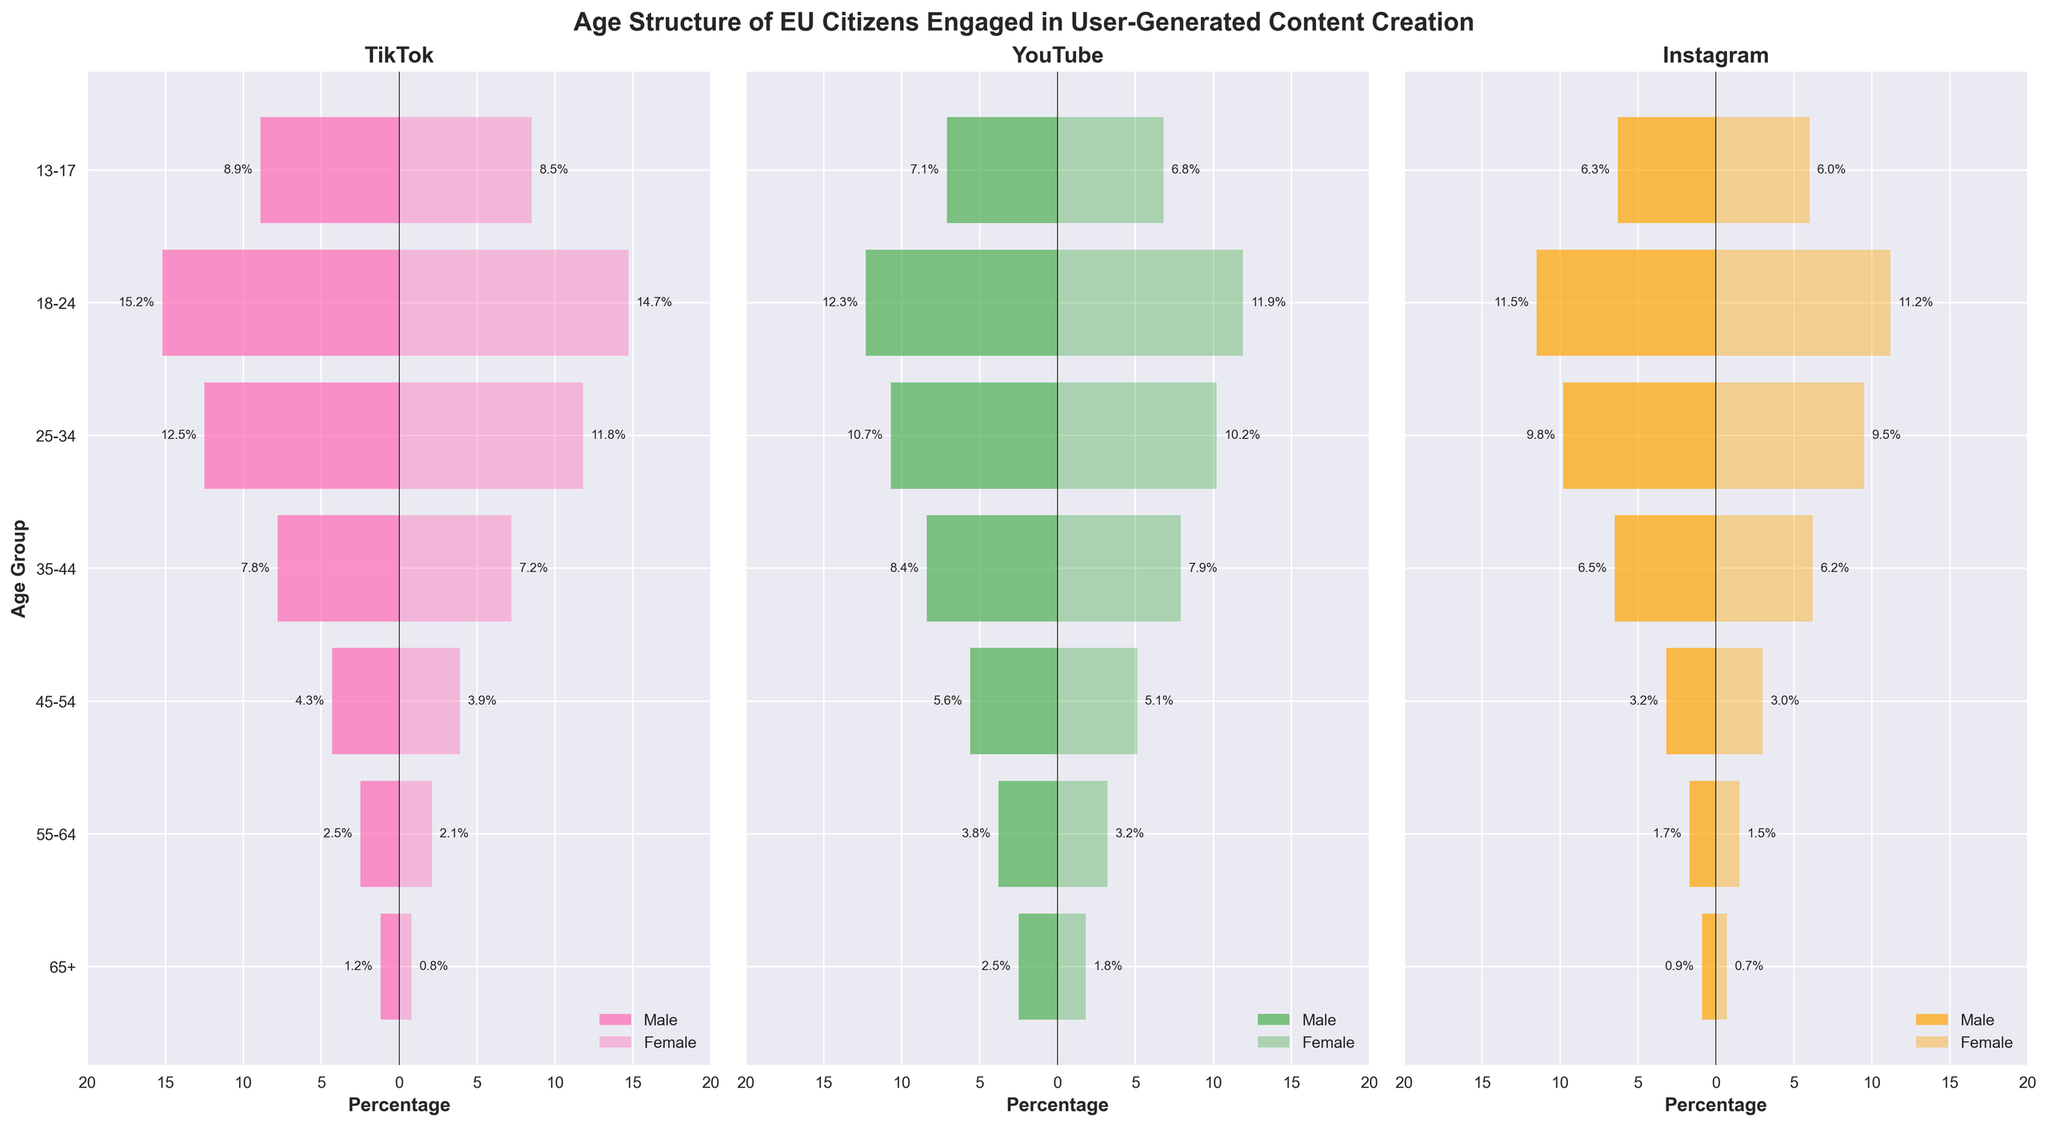What is the title of the figure? The title of the figure is usually located at the top, central portion of the figure. The title here is given as 'Age Structure of EU Citizens Engaged in User-Generated Content Creation'.
Answer: Age Structure of EU Citizens Engaged in User-Generated Content Creation Which age group has the highest engagement in TikTok among males? To find the highest engagement, we look at the 'Male TikTok' bar for each age group and identify which bar has the largest percentage. The highest percentage for males on TikTok is 15.2% in the 18-24 age group.
Answer: 18-24 What is the percentage of females aged 25-34 on YouTube? Locate the 'Female YouTube' bar for the 25-34 age group, and check the percentage value displayed alongside the bar, which is 10.2%.
Answer: 10.2% Which platform has the highest engagement for the 13-17 age group? Compare the percentages for both males and females across all platforms (TikTok, YouTube, Instagram) for the 13-17 age group. TikTok shows the highest engagement with males at 8.9% and females at 8.5%.
Answer: TikTok How does male engagement on Instagram differ between the 45-54 and 55-64 age groups? First, find the values for 'Male Instagram' for the 45-54 age group (3.2%) and the 55-64 age group (1.7%). Then calculate the difference: 3.2% - 1.7% = 1.5%.
Answer: 1.5% Which gender has higher engagement on YouTube for the 35-44 age group? Look at the 'Male YouTube' and 'Female YouTube' bars for the 35-44 age group. Males have an engagement of 8.4% while females have an engagement of 7.9%.
Answer: Male What is the average engagement for males across all platforms in the 18-24 age group? To get the average, add the male percentages for 18-24 across all platforms: TikTok (15.2%), YouTube (12.3%), Instagram (11.5%). Sum = 15.2 + 12.3 + 11.5 = 39%. Then divide by 3: 39% / 3 = 13%.
Answer: 13% Is there any age group where more females are engaged on TikTok than any other platform? We need to compare female engagement percentages within the same age group across all platforms. In every age group, female engagement is higher on TikTok than other platforms. So, yes, this is true for every age group listed.
Answer: Yes 